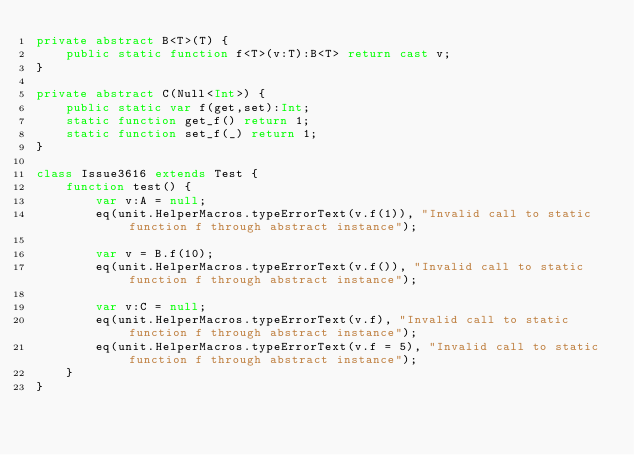<code> <loc_0><loc_0><loc_500><loc_500><_Haxe_>private abstract B<T>(T) {
	public static function f<T>(v:T):B<T> return cast v;
}

private abstract C(Null<Int>) {
	public static var f(get,set):Int;
	static function get_f() return 1;
	static function set_f(_) return 1;
}

class Issue3616 extends Test {
	function test() {
		var v:A = null;
		eq(unit.HelperMacros.typeErrorText(v.f(1)), "Invalid call to static function f through abstract instance");

		var v = B.f(10);
		eq(unit.HelperMacros.typeErrorText(v.f()), "Invalid call to static function f through abstract instance");

		var v:C = null;
		eq(unit.HelperMacros.typeErrorText(v.f), "Invalid call to static function f through abstract instance");
		eq(unit.HelperMacros.typeErrorText(v.f = 5), "Invalid call to static function f through abstract instance");
	}
}
</code> 